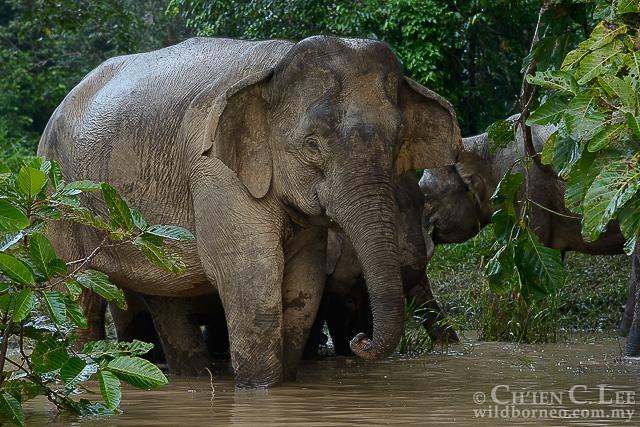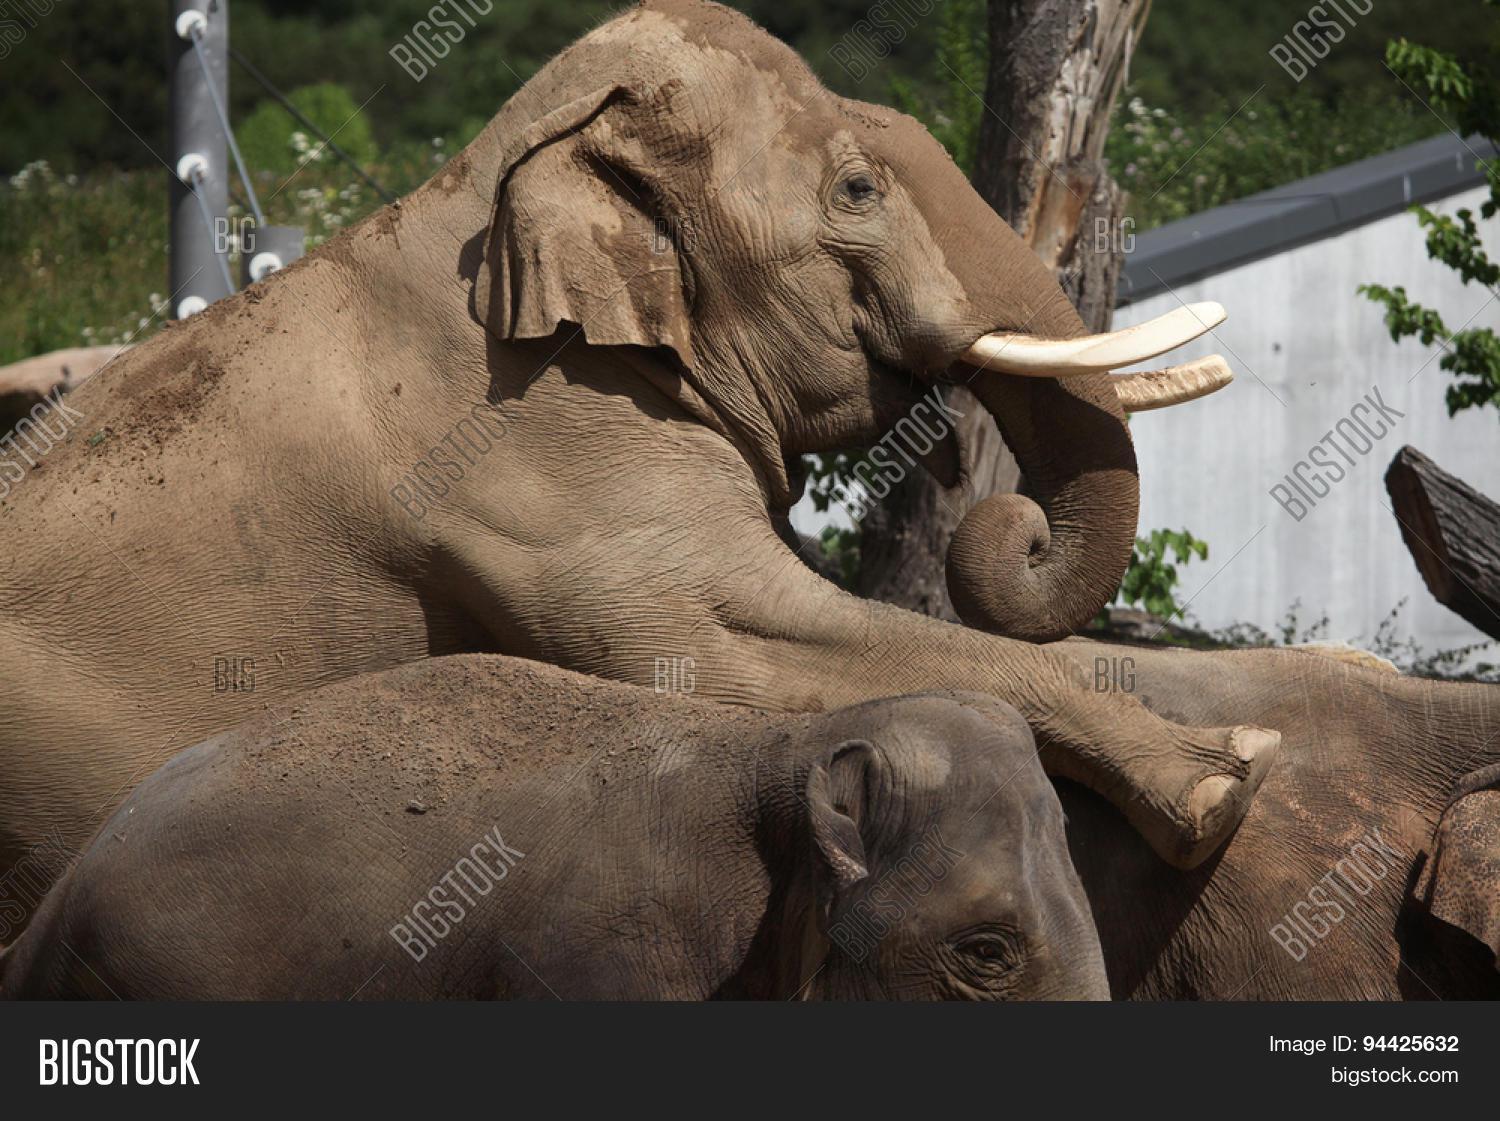The first image is the image on the left, the second image is the image on the right. Assess this claim about the two images: "there is one elephant on the left image". Correct or not? Answer yes or no. No. 